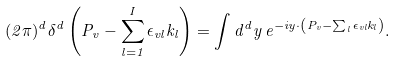Convert formula to latex. <formula><loc_0><loc_0><loc_500><loc_500>( 2 \pi ) ^ { d } \delta ^ { d } \left ( P _ { v } - \sum _ { l = 1 } ^ { I } \epsilon _ { v l } k _ { l } \right ) = \int d ^ { d } y \, e ^ { - i y \cdot \left ( P _ { v } - \sum _ { l } \epsilon _ { v l } k _ { l } \right ) } .</formula> 